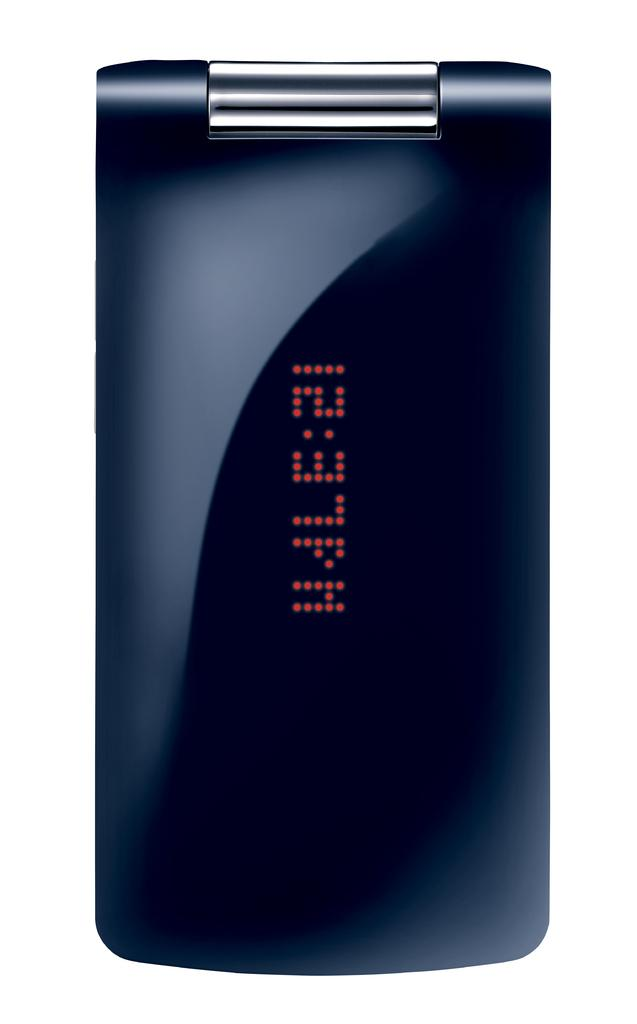<image>
Render a clear and concise summary of the photo. The cover of a black cell phone with the clock reading 12:37 pm. 